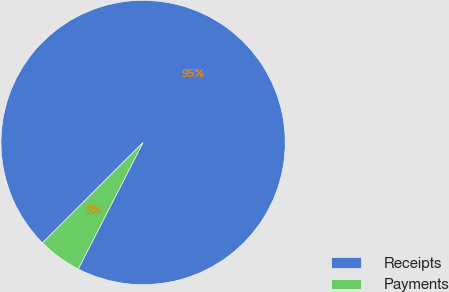<chart> <loc_0><loc_0><loc_500><loc_500><pie_chart><fcel>Receipts<fcel>Payments<nl><fcel>95.02%<fcel>4.98%<nl></chart> 